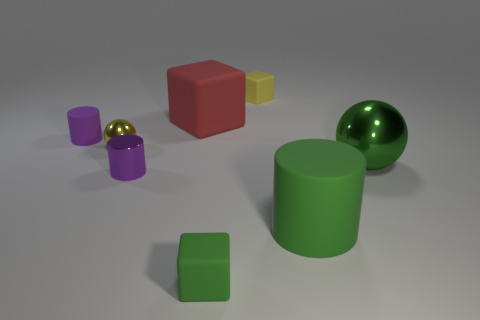The purple matte object that is the same shape as the purple metal thing is what size?
Provide a succinct answer. Small. There is a ball to the right of the tiny rubber thing in front of the purple metal cylinder; what number of shiny objects are behind it?
Keep it short and to the point. 1. What number of cylinders are tiny shiny things or matte objects?
Provide a short and direct response. 3. What color is the cube that is in front of the purple cylinder behind the green object that is behind the big green rubber cylinder?
Provide a short and direct response. Green. How many other things are there of the same size as the green metal sphere?
Provide a short and direct response. 2. Is there anything else that has the same shape as the yellow metallic object?
Offer a terse response. Yes. What color is the other object that is the same shape as the big metal thing?
Your answer should be compact. Yellow. What is the color of the big cylinder that is the same material as the tiny green block?
Give a very brief answer. Green. Are there the same number of cylinders on the left side of the purple matte object and gray metal cylinders?
Offer a terse response. Yes. There is a purple cylinder behind the yellow sphere; does it have the same size as the big red matte object?
Your answer should be compact. No. 